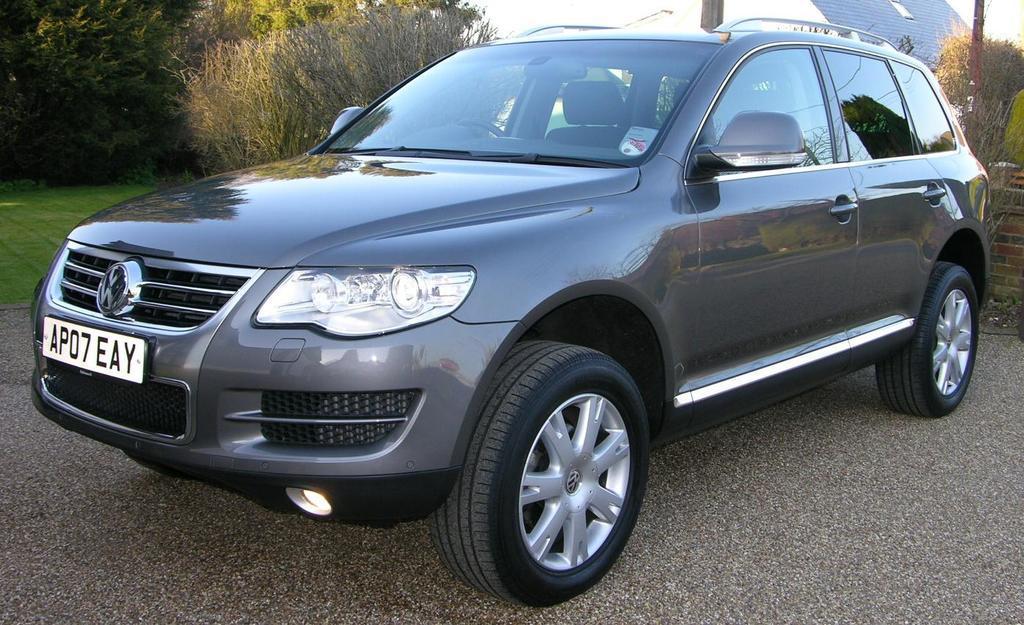How would you summarize this image in a sentence or two? It is a car in grey color on the road, on the left side there are trees. 